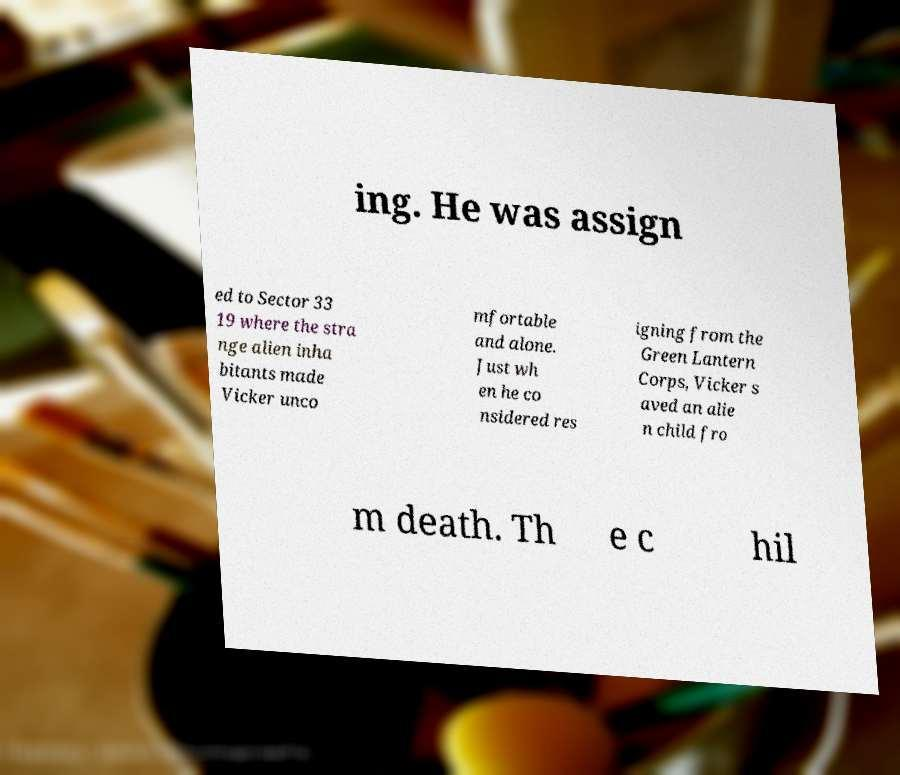Can you accurately transcribe the text from the provided image for me? ing. He was assign ed to Sector 33 19 where the stra nge alien inha bitants made Vicker unco mfortable and alone. Just wh en he co nsidered res igning from the Green Lantern Corps, Vicker s aved an alie n child fro m death. Th e c hil 